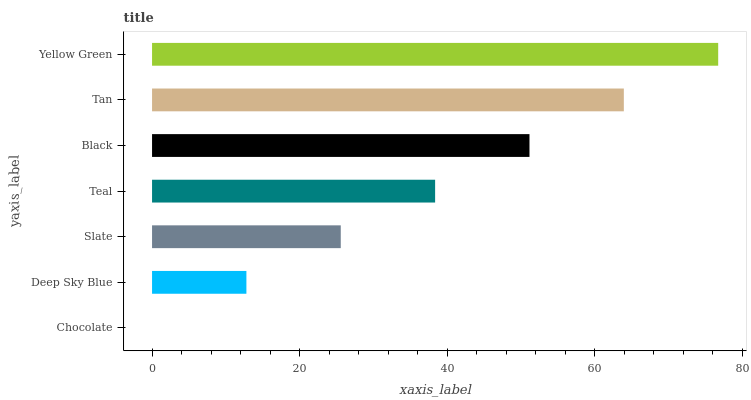Is Chocolate the minimum?
Answer yes or no. Yes. Is Yellow Green the maximum?
Answer yes or no. Yes. Is Deep Sky Blue the minimum?
Answer yes or no. No. Is Deep Sky Blue the maximum?
Answer yes or no. No. Is Deep Sky Blue greater than Chocolate?
Answer yes or no. Yes. Is Chocolate less than Deep Sky Blue?
Answer yes or no. Yes. Is Chocolate greater than Deep Sky Blue?
Answer yes or no. No. Is Deep Sky Blue less than Chocolate?
Answer yes or no. No. Is Teal the high median?
Answer yes or no. Yes. Is Teal the low median?
Answer yes or no. Yes. Is Chocolate the high median?
Answer yes or no. No. Is Black the low median?
Answer yes or no. No. 